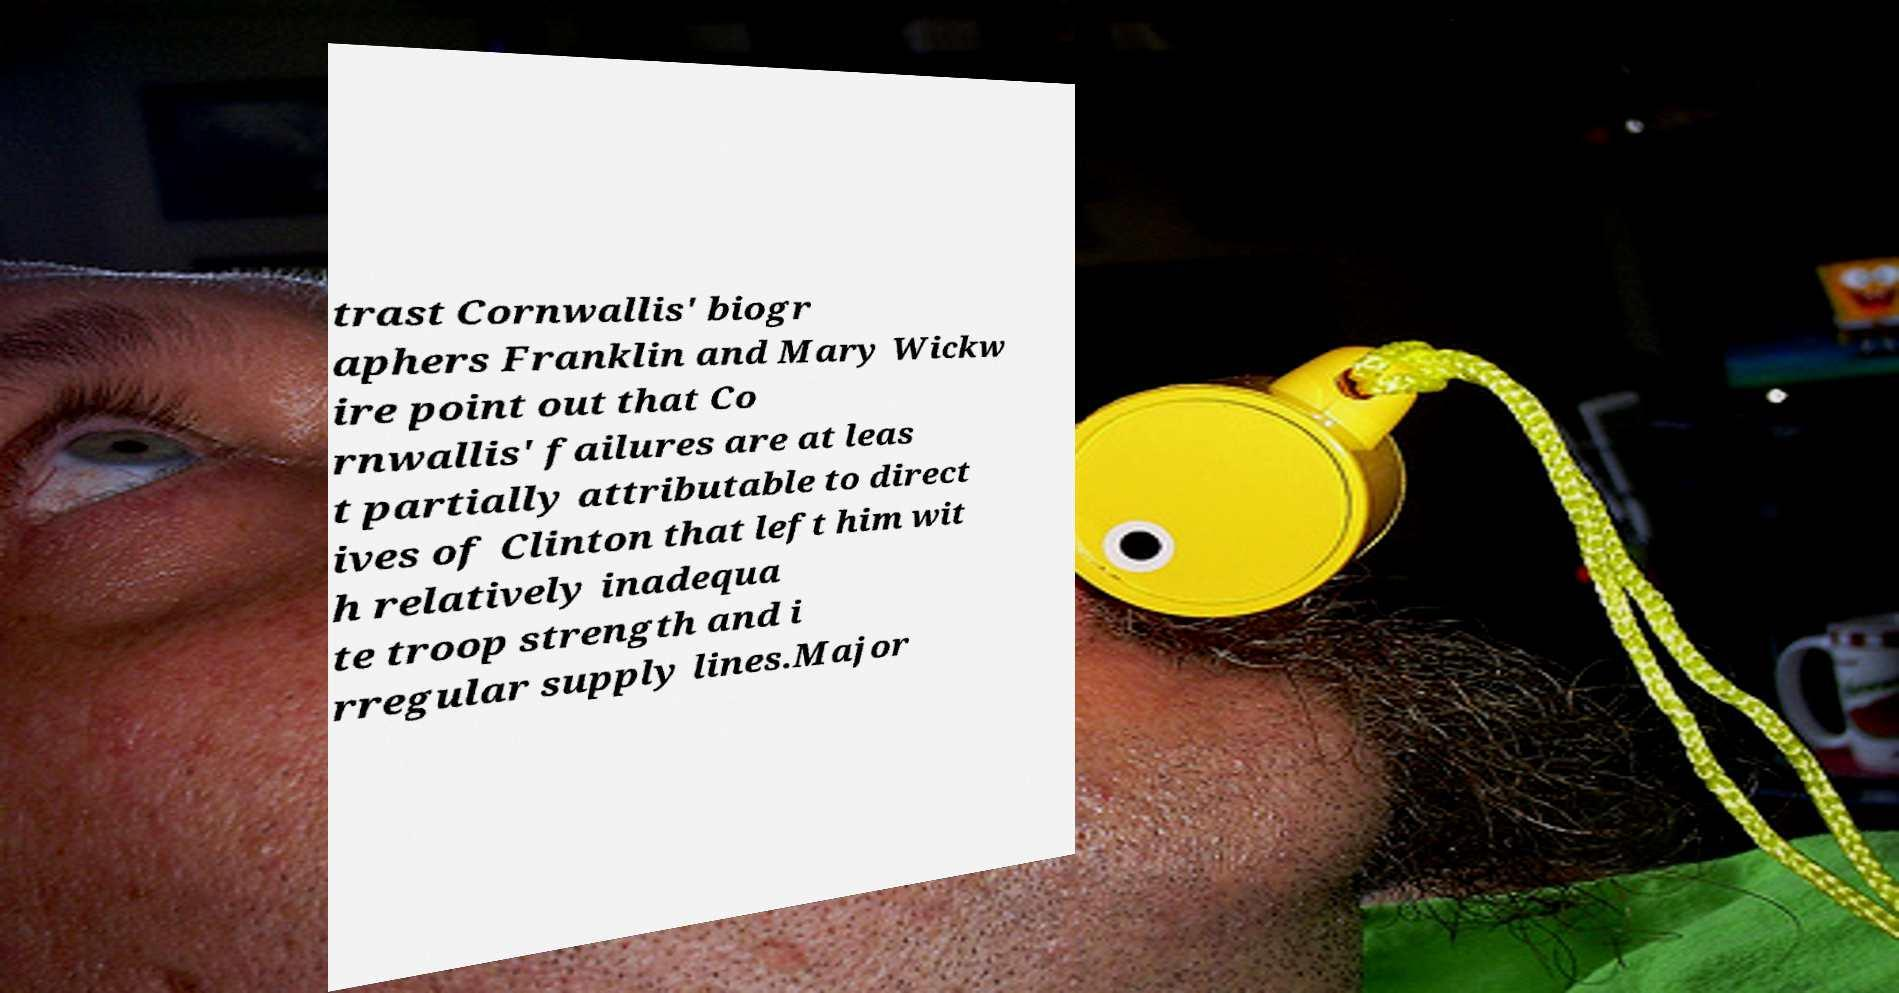Can you read and provide the text displayed in the image?This photo seems to have some interesting text. Can you extract and type it out for me? trast Cornwallis' biogr aphers Franklin and Mary Wickw ire point out that Co rnwallis' failures are at leas t partially attributable to direct ives of Clinton that left him wit h relatively inadequa te troop strength and i rregular supply lines.Major 